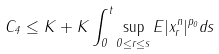Convert formula to latex. <formula><loc_0><loc_0><loc_500><loc_500>C _ { 4 } \leq K + K \int _ { 0 } ^ { t } \sup _ { 0 \leq r \leq s } E | x _ { r } ^ { n } | ^ { p _ { 0 } } d s</formula> 